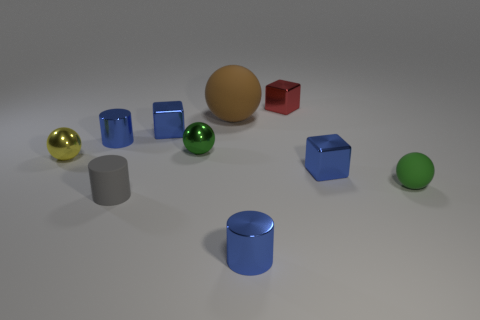Subtract all spheres. How many objects are left? 6 Subtract all gray rubber objects. Subtract all small red metal objects. How many objects are left? 8 Add 4 small gray rubber cylinders. How many small gray rubber cylinders are left? 5 Add 8 tiny gray matte cylinders. How many tiny gray matte cylinders exist? 9 Subtract 1 green spheres. How many objects are left? 9 